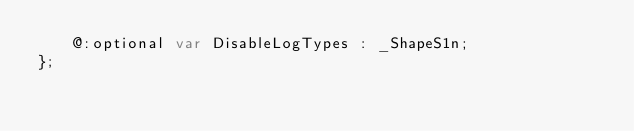Convert code to text. <code><loc_0><loc_0><loc_500><loc_500><_Haxe_>    @:optional var DisableLogTypes : _ShapeS1n;
};
</code> 